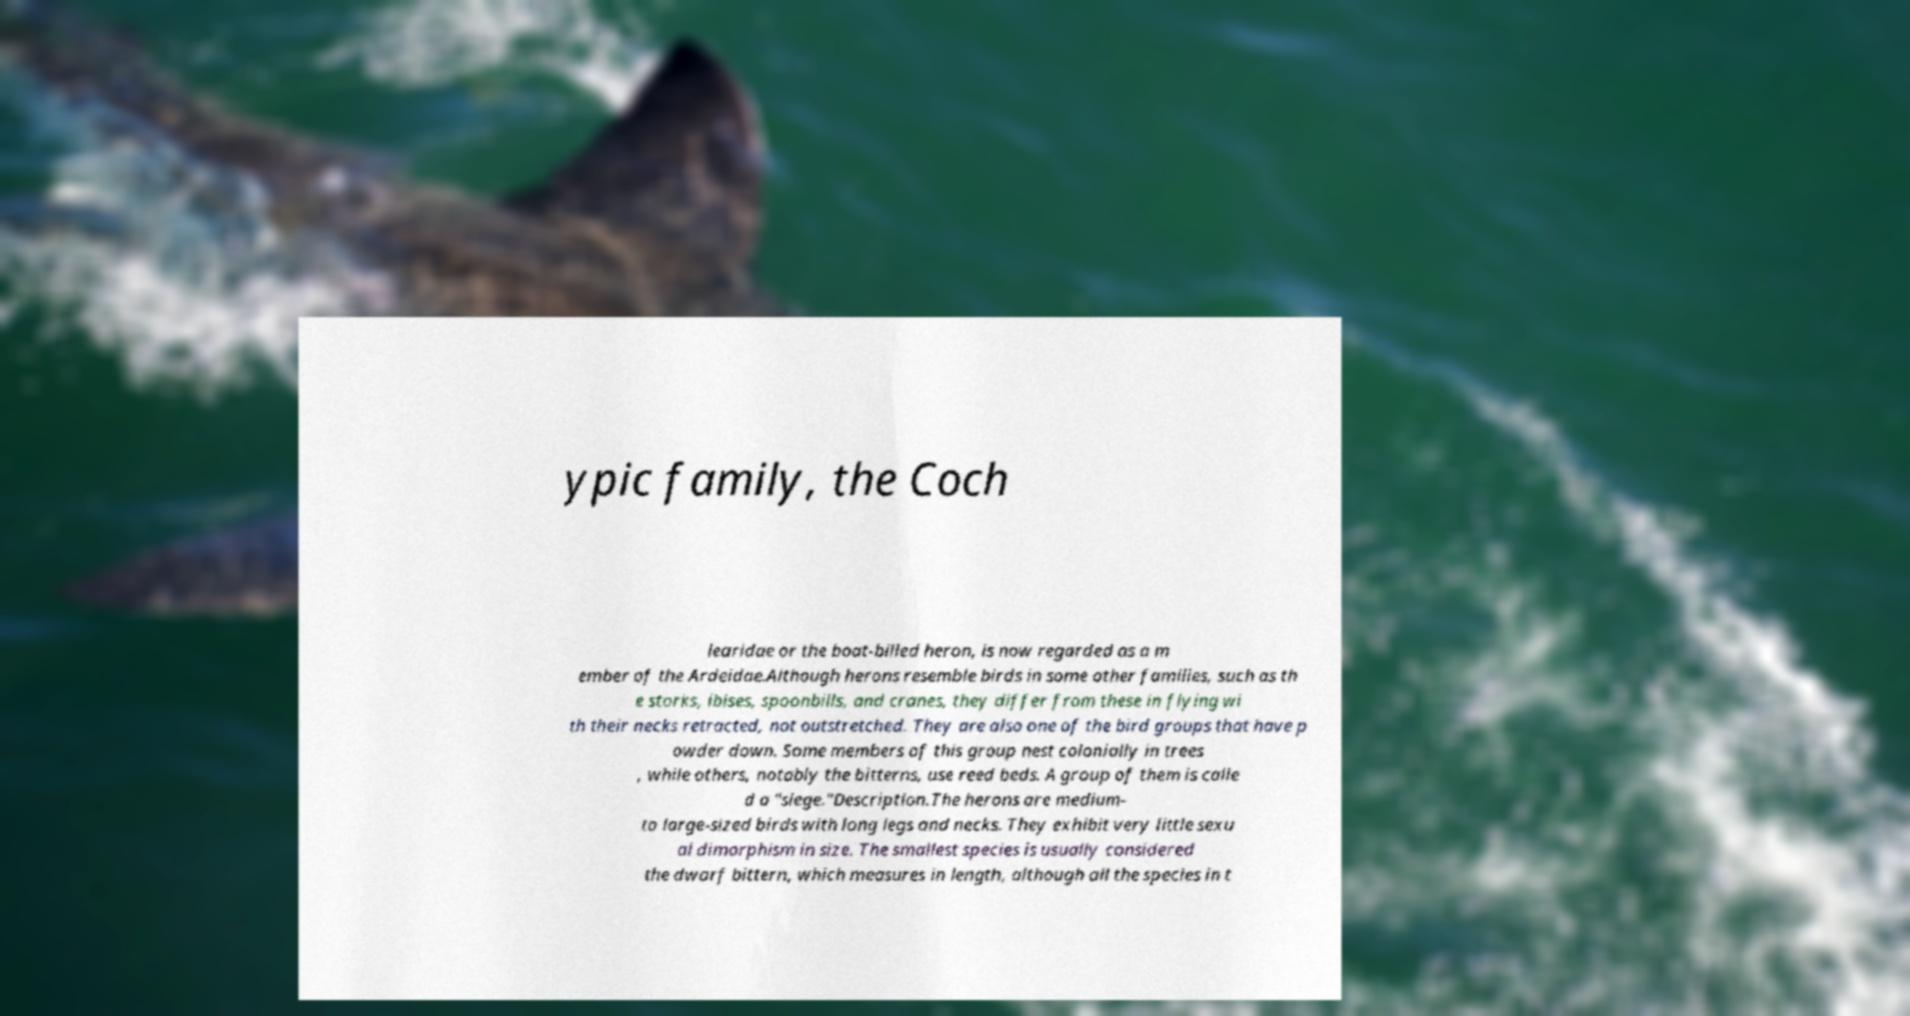For documentation purposes, I need the text within this image transcribed. Could you provide that? ypic family, the Coch learidae or the boat-billed heron, is now regarded as a m ember of the Ardeidae.Although herons resemble birds in some other families, such as th e storks, ibises, spoonbills, and cranes, they differ from these in flying wi th their necks retracted, not outstretched. They are also one of the bird groups that have p owder down. Some members of this group nest colonially in trees , while others, notably the bitterns, use reed beds. A group of them is calle d a "siege."Description.The herons are medium- to large-sized birds with long legs and necks. They exhibit very little sexu al dimorphism in size. The smallest species is usually considered the dwarf bittern, which measures in length, although all the species in t 